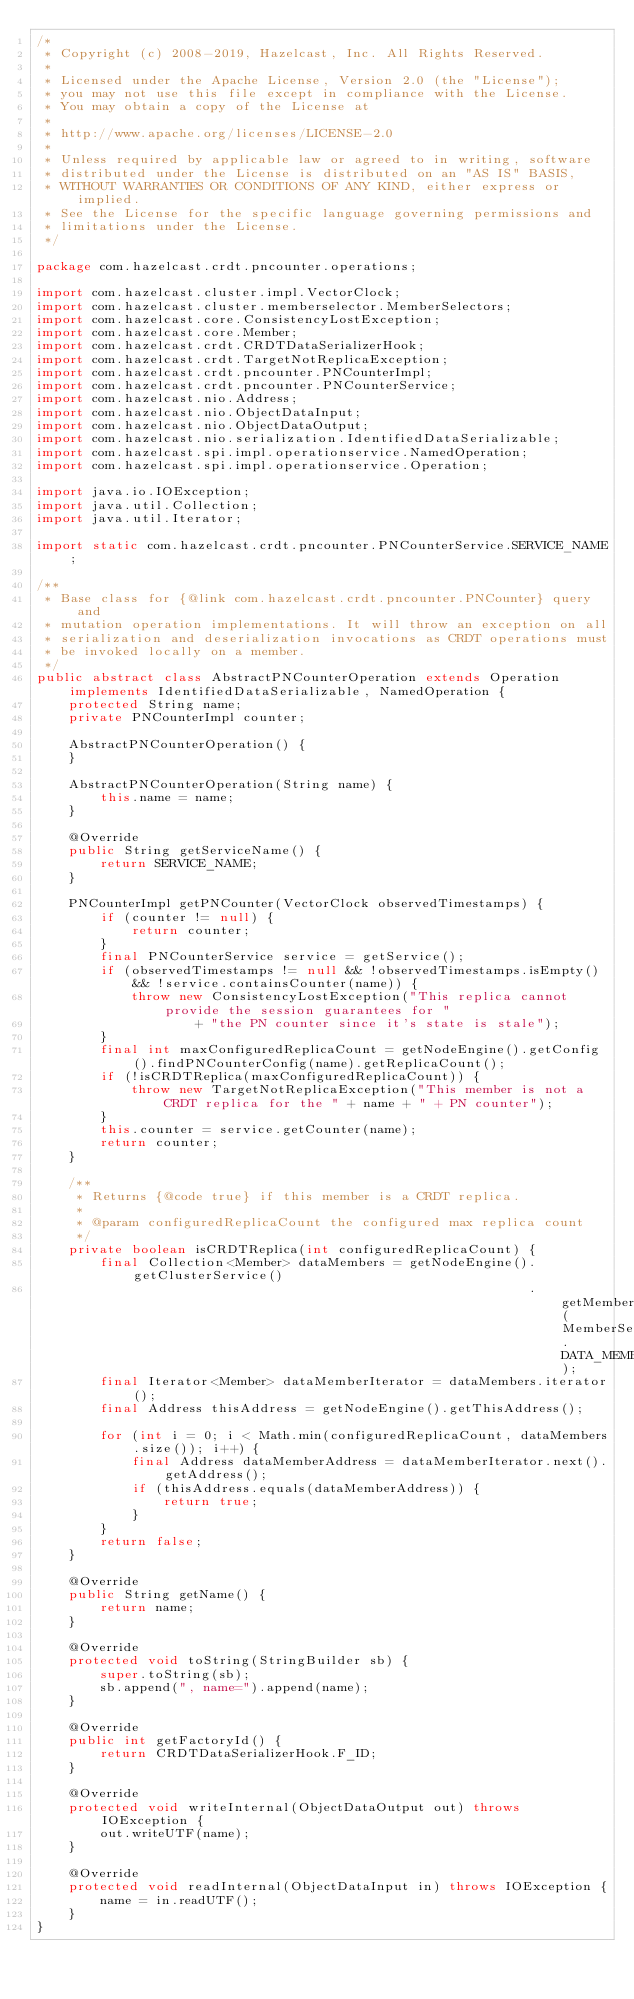Convert code to text. <code><loc_0><loc_0><loc_500><loc_500><_Java_>/*
 * Copyright (c) 2008-2019, Hazelcast, Inc. All Rights Reserved.
 *
 * Licensed under the Apache License, Version 2.0 (the "License");
 * you may not use this file except in compliance with the License.
 * You may obtain a copy of the License at
 *
 * http://www.apache.org/licenses/LICENSE-2.0
 *
 * Unless required by applicable law or agreed to in writing, software
 * distributed under the License is distributed on an "AS IS" BASIS,
 * WITHOUT WARRANTIES OR CONDITIONS OF ANY KIND, either express or implied.
 * See the License for the specific language governing permissions and
 * limitations under the License.
 */

package com.hazelcast.crdt.pncounter.operations;

import com.hazelcast.cluster.impl.VectorClock;
import com.hazelcast.cluster.memberselector.MemberSelectors;
import com.hazelcast.core.ConsistencyLostException;
import com.hazelcast.core.Member;
import com.hazelcast.crdt.CRDTDataSerializerHook;
import com.hazelcast.crdt.TargetNotReplicaException;
import com.hazelcast.crdt.pncounter.PNCounterImpl;
import com.hazelcast.crdt.pncounter.PNCounterService;
import com.hazelcast.nio.Address;
import com.hazelcast.nio.ObjectDataInput;
import com.hazelcast.nio.ObjectDataOutput;
import com.hazelcast.nio.serialization.IdentifiedDataSerializable;
import com.hazelcast.spi.impl.operationservice.NamedOperation;
import com.hazelcast.spi.impl.operationservice.Operation;

import java.io.IOException;
import java.util.Collection;
import java.util.Iterator;

import static com.hazelcast.crdt.pncounter.PNCounterService.SERVICE_NAME;

/**
 * Base class for {@link com.hazelcast.crdt.pncounter.PNCounter} query and
 * mutation operation implementations. It will throw an exception on all
 * serialization and deserialization invocations as CRDT operations must
 * be invoked locally on a member.
 */
public abstract class AbstractPNCounterOperation extends Operation implements IdentifiedDataSerializable, NamedOperation {
    protected String name;
    private PNCounterImpl counter;

    AbstractPNCounterOperation() {
    }

    AbstractPNCounterOperation(String name) {
        this.name = name;
    }

    @Override
    public String getServiceName() {
        return SERVICE_NAME;
    }

    PNCounterImpl getPNCounter(VectorClock observedTimestamps) {
        if (counter != null) {
            return counter;
        }
        final PNCounterService service = getService();
        if (observedTimestamps != null && !observedTimestamps.isEmpty() && !service.containsCounter(name)) {
            throw new ConsistencyLostException("This replica cannot provide the session guarantees for "
                    + "the PN counter since it's state is stale");
        }
        final int maxConfiguredReplicaCount = getNodeEngine().getConfig().findPNCounterConfig(name).getReplicaCount();
        if (!isCRDTReplica(maxConfiguredReplicaCount)) {
            throw new TargetNotReplicaException("This member is not a CRDT replica for the " + name + " + PN counter");
        }
        this.counter = service.getCounter(name);
        return counter;
    }

    /**
     * Returns {@code true} if this member is a CRDT replica.
     *
     * @param configuredReplicaCount the configured max replica count
     */
    private boolean isCRDTReplica(int configuredReplicaCount) {
        final Collection<Member> dataMembers = getNodeEngine().getClusterService()
                                                              .getMembers(MemberSelectors.DATA_MEMBER_SELECTOR);
        final Iterator<Member> dataMemberIterator = dataMembers.iterator();
        final Address thisAddress = getNodeEngine().getThisAddress();

        for (int i = 0; i < Math.min(configuredReplicaCount, dataMembers.size()); i++) {
            final Address dataMemberAddress = dataMemberIterator.next().getAddress();
            if (thisAddress.equals(dataMemberAddress)) {
                return true;
            }
        }
        return false;
    }

    @Override
    public String getName() {
        return name;
    }

    @Override
    protected void toString(StringBuilder sb) {
        super.toString(sb);
        sb.append(", name=").append(name);
    }

    @Override
    public int getFactoryId() {
        return CRDTDataSerializerHook.F_ID;
    }

    @Override
    protected void writeInternal(ObjectDataOutput out) throws IOException {
        out.writeUTF(name);
    }

    @Override
    protected void readInternal(ObjectDataInput in) throws IOException {
        name = in.readUTF();
    }
}
</code> 